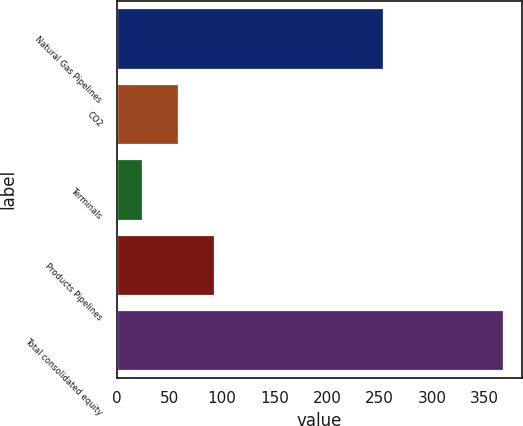Convert chart. <chart><loc_0><loc_0><loc_500><loc_500><bar_chart><fcel>Natural Gas Pipelines<fcel>CO2<fcel>Terminals<fcel>Products Pipelines<fcel>Total consolidated equity<nl><fcel>253<fcel>58.3<fcel>24<fcel>92.6<fcel>367<nl></chart> 